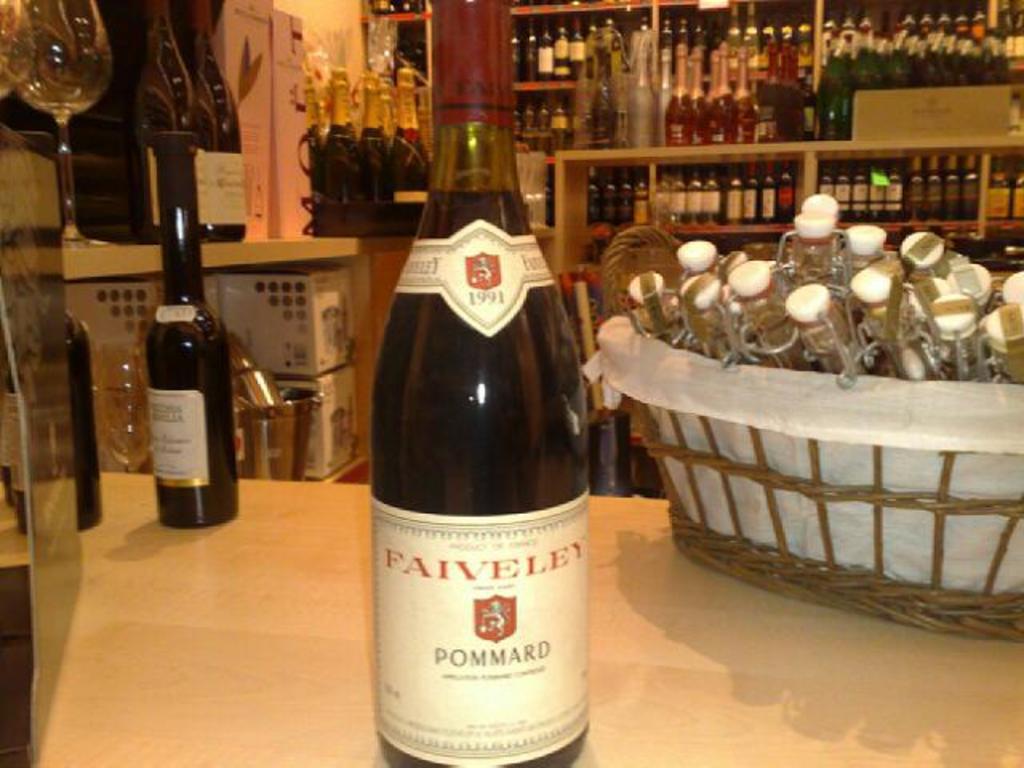What kind of wine is this?
Ensure brevity in your answer.  Pommard. Faiveley red wine?
Your answer should be very brief. Yes. 